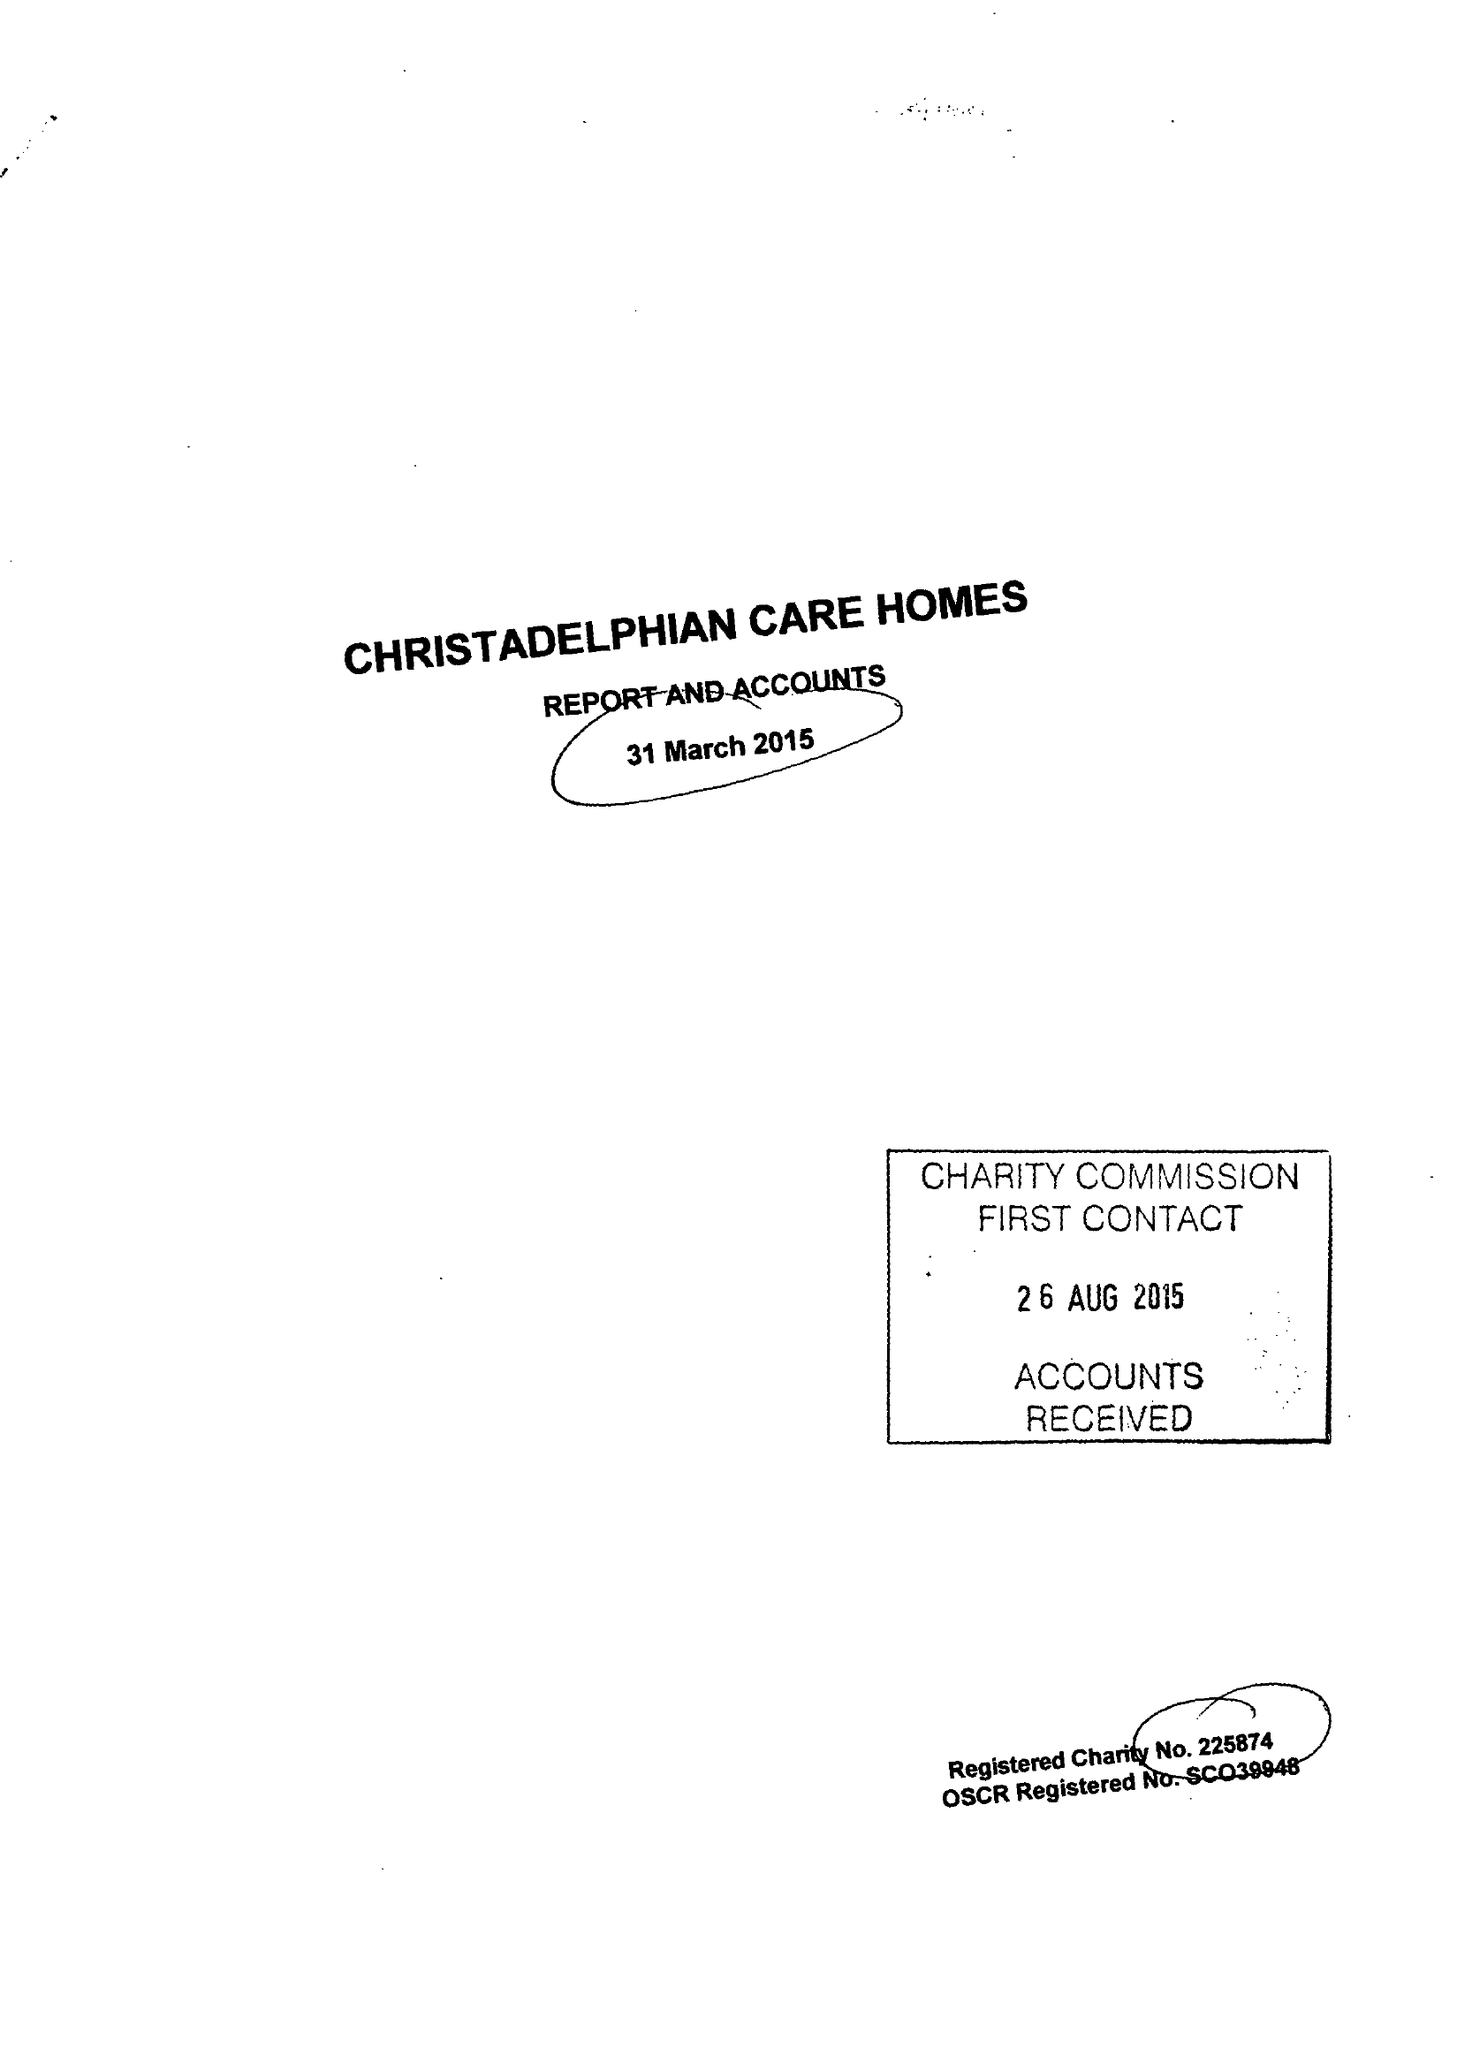What is the value for the charity_name?
Answer the question using a single word or phrase. Christadelphian Care Homes 